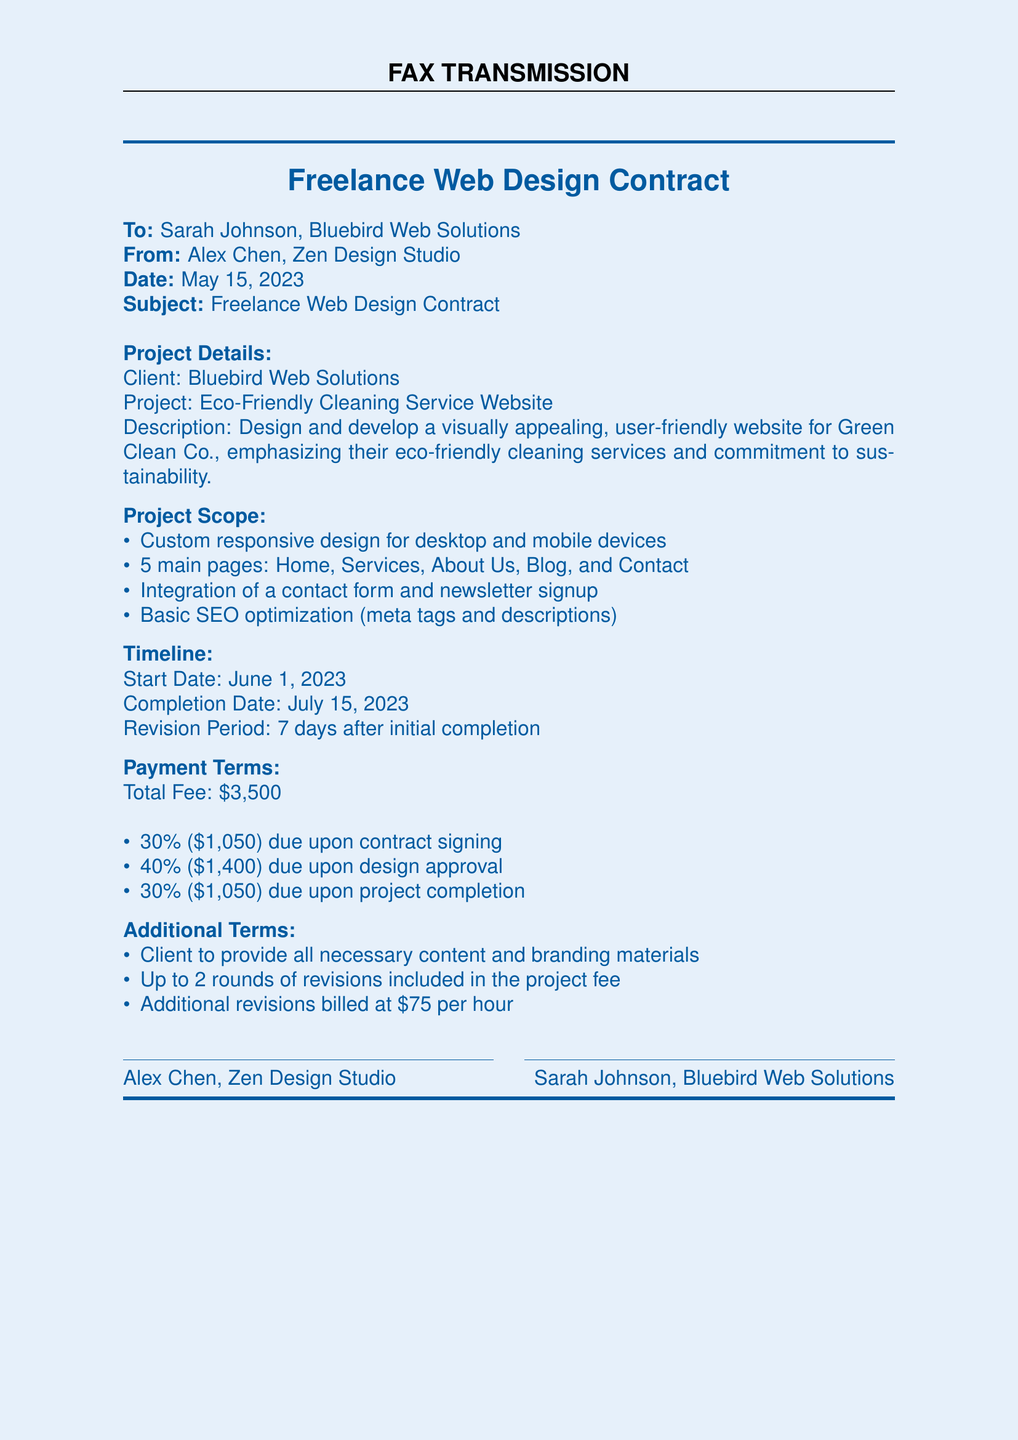What is the project title? The project title is directly mentioned in the document, which is "Eco-Friendly Cleaning Service Website."
Answer: Eco-Friendly Cleaning Service Website Who is the client? The client for the project is specified in the document, identified as "Bluebird Web Solutions."
Answer: Bluebird Web Solutions What is the total fee for the project? The total fee listed in the document is a specific amount for the project, which is $3,500.
Answer: $3,500 When is the project completion date? The completion date is outlined in the timeline section of the document, specified as July 15, 2023.
Answer: July 15, 2023 What percentage is due upon contract signing? The payment terms indicate the percentage due upon signing the contract, which is 30%.
Answer: 30% How many main pages will be created? The project scope lists the number of main pages to be created, which is 5.
Answer: 5 What is the revision period after initial completion? The timeline section describes the revision period, specified as 7 days.
Answer: 7 days What is the rate for additional revisions? The additional terms section states the billing rate for additional revisions, which is $75 per hour.
Answer: $75 per hour 